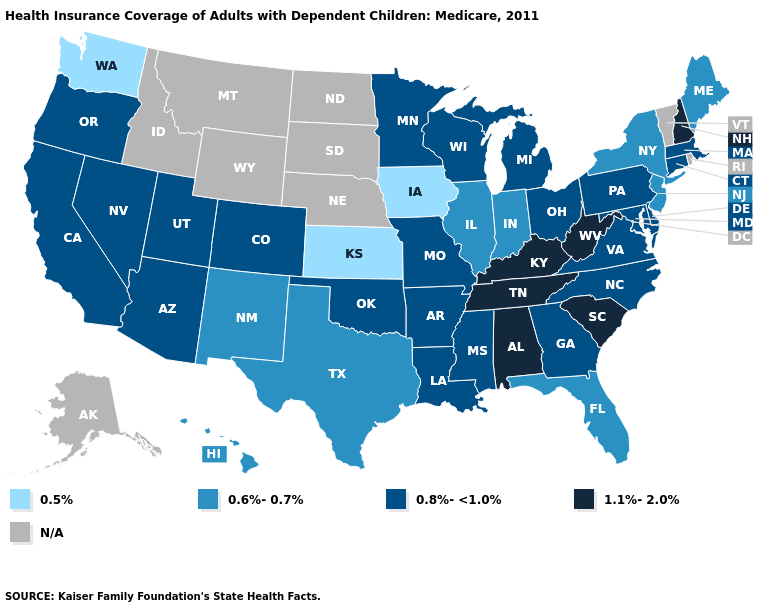Name the states that have a value in the range N/A?
Keep it brief. Alaska, Idaho, Montana, Nebraska, North Dakota, Rhode Island, South Dakota, Vermont, Wyoming. What is the highest value in states that border Tennessee?
Short answer required. 1.1%-2.0%. What is the value of Nebraska?
Answer briefly. N/A. Name the states that have a value in the range 0.8%-<1.0%?
Keep it brief. Arizona, Arkansas, California, Colorado, Connecticut, Delaware, Georgia, Louisiana, Maryland, Massachusetts, Michigan, Minnesota, Mississippi, Missouri, Nevada, North Carolina, Ohio, Oklahoma, Oregon, Pennsylvania, Utah, Virginia, Wisconsin. Is the legend a continuous bar?
Concise answer only. No. What is the value of Iowa?
Short answer required. 0.5%. Name the states that have a value in the range 1.1%-2.0%?
Keep it brief. Alabama, Kentucky, New Hampshire, South Carolina, Tennessee, West Virginia. Does Kansas have the lowest value in the USA?
Keep it brief. Yes. What is the highest value in states that border Rhode Island?
Short answer required. 0.8%-<1.0%. Which states have the lowest value in the USA?
Short answer required. Iowa, Kansas, Washington. Name the states that have a value in the range 0.5%?
Keep it brief. Iowa, Kansas, Washington. What is the value of Kansas?
Answer briefly. 0.5%. What is the value of New York?
Give a very brief answer. 0.6%-0.7%. What is the value of Michigan?
Keep it brief. 0.8%-<1.0%. How many symbols are there in the legend?
Short answer required. 5. 